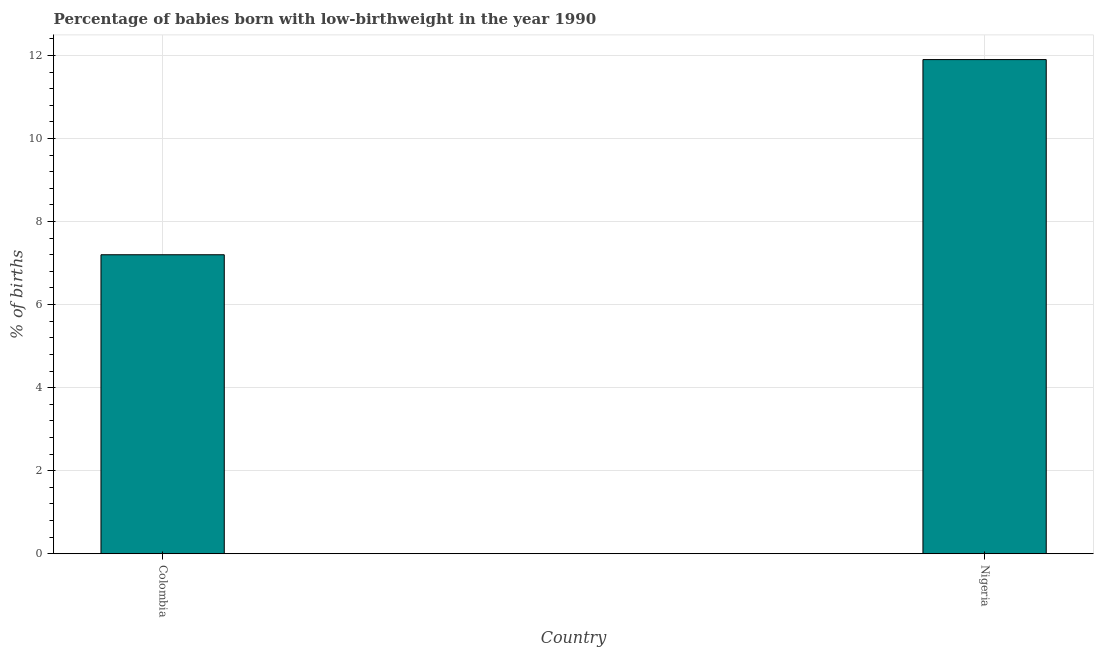Does the graph contain grids?
Provide a succinct answer. Yes. What is the title of the graph?
Keep it short and to the point. Percentage of babies born with low-birthweight in the year 1990. What is the label or title of the X-axis?
Ensure brevity in your answer.  Country. What is the label or title of the Y-axis?
Give a very brief answer. % of births. Across all countries, what is the minimum percentage of babies who were born with low-birthweight?
Keep it short and to the point. 7.2. In which country was the percentage of babies who were born with low-birthweight maximum?
Provide a short and direct response. Nigeria. What is the difference between the percentage of babies who were born with low-birthweight in Colombia and Nigeria?
Offer a terse response. -4.7. What is the average percentage of babies who were born with low-birthweight per country?
Offer a very short reply. 9.55. What is the median percentage of babies who were born with low-birthweight?
Make the answer very short. 9.55. In how many countries, is the percentage of babies who were born with low-birthweight greater than 9.6 %?
Your answer should be very brief. 1. What is the ratio of the percentage of babies who were born with low-birthweight in Colombia to that in Nigeria?
Ensure brevity in your answer.  0.6. Are all the bars in the graph horizontal?
Provide a short and direct response. No. How many countries are there in the graph?
Make the answer very short. 2. What is the ratio of the % of births in Colombia to that in Nigeria?
Offer a very short reply. 0.6. 